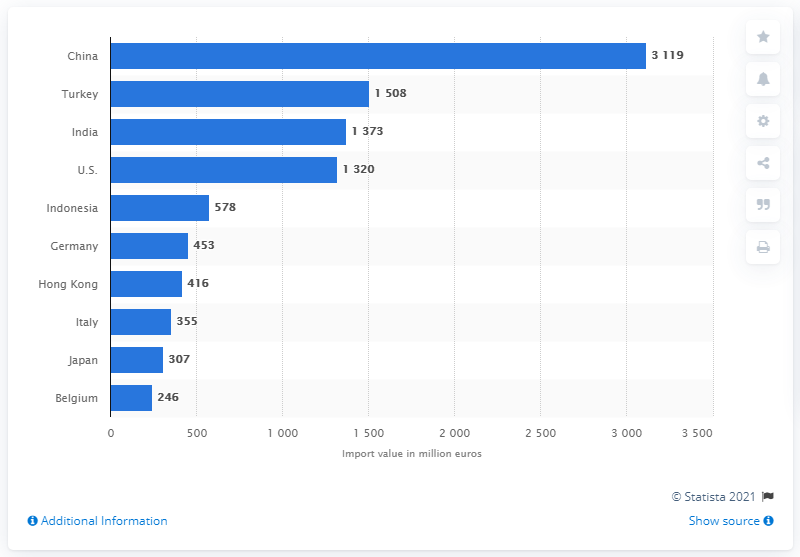Draw attention to some important aspects in this diagram. In 2013, the value of textile machinery imported to Hong Kong was approximately 416 million US dollars. 